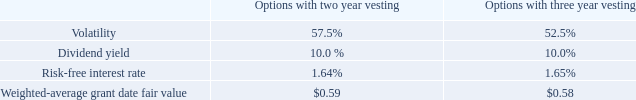Stock Option Award Amendment
The Board of Directors has in 2019 amended and restated the 2011 Equity Incentive Plan to reserve an additional 1,000,000 stock options for issuance. The stock options have been allocated amongst management and employees of the Company.
As of December 31, 2019, the Company has granted 755,000 and 234,000 options with vesting over a period of two and three years, respectively, and an exercise price of $4.70 per share.
The Company has used the Black-Scholes option pricing model to measure the grant date fair value of the options with the following assumptions applied to the model;
The expected volatility was based on historical volatility observed from historical company-specific data during the two years prior to the grant date.
The compensation expense related to the stock option awards was $0.1 million for the year ended December 31, 2019 and the remaining unrecognized cost related to non-vested stock options was $0.5 million with a remaining average remaining vesting period of 2.1 years.
What are the number of options granted by the company with vesting over a period of two and three years, respectively?  755,000, 234,000. What is the exercise price per share of options with vesting over a period of two and three years, respectively granted by the company? $4.70, $4.70. What are the respective volatility of options with 2 and 3 years vesting? 57.5%, 52.5%. What is the change in Weighted-average grant date fair value between the options with two year vesting and three year vesting? 0.59-0.58
Answer: 0.01. What is the average dividend yield between options with vesting over a period of two and three years?
Answer scale should be: percent. (10% + 10%)/2  
Answer: 10. What is the average volatility between the options with 2 and 3 years vesting?
Answer scale should be: percent. (52.5% + 57.5%)/2 
Answer: 55. 